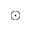Convert formula to latex. <formula><loc_0><loc_0><loc_500><loc_500>\odot</formula> 